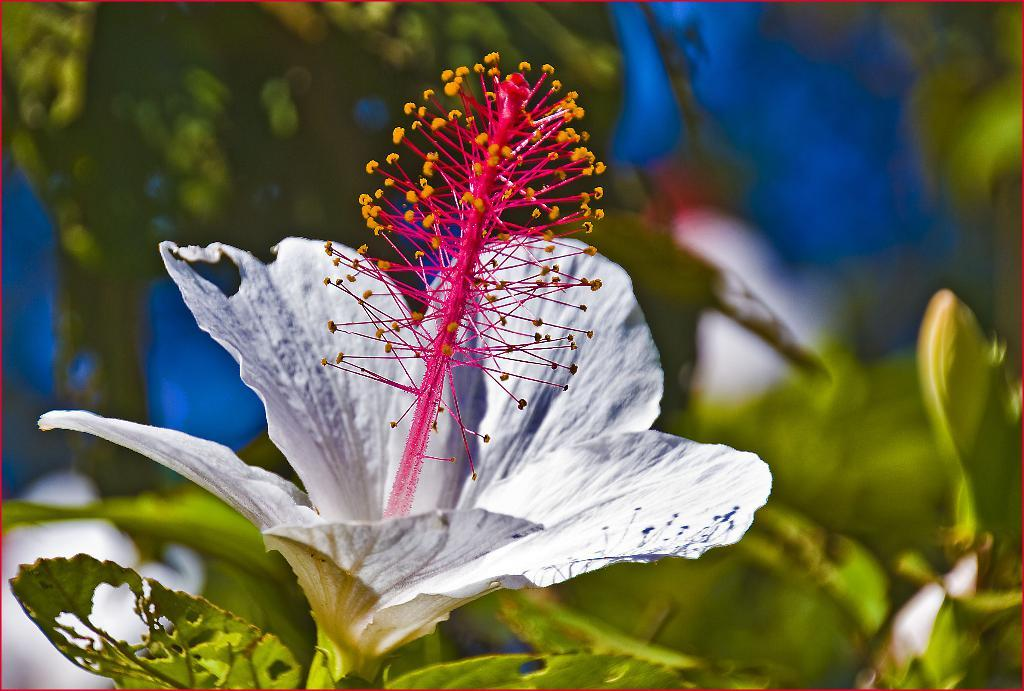What type of plant can be seen in the picture? There is a flower in the picture. Are there any other parts of the plant visible in the image? Yes, there are leaves in the picture. What type of account is associated with the flower in the picture? There is no account mentioned or depicted in the image; it only features a flower and leaves. 